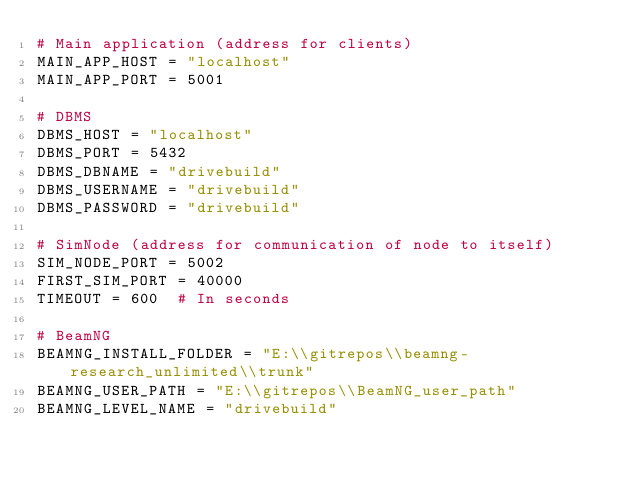Convert code to text. <code><loc_0><loc_0><loc_500><loc_500><_Python_># Main application (address for clients)
MAIN_APP_HOST = "localhost"
MAIN_APP_PORT = 5001

# DBMS
DBMS_HOST = "localhost"
DBMS_PORT = 5432
DBMS_DBNAME = "drivebuild"
DBMS_USERNAME = "drivebuild"
DBMS_PASSWORD = "drivebuild"

# SimNode (address for communication of node to itself)
SIM_NODE_PORT = 5002
FIRST_SIM_PORT = 40000
TIMEOUT = 600  # In seconds

# BeamNG
BEAMNG_INSTALL_FOLDER = "E:\\gitrepos\\beamng-research_unlimited\\trunk"
BEAMNG_USER_PATH = "E:\\gitrepos\\BeamNG_user_path"
BEAMNG_LEVEL_NAME = "drivebuild"
</code> 